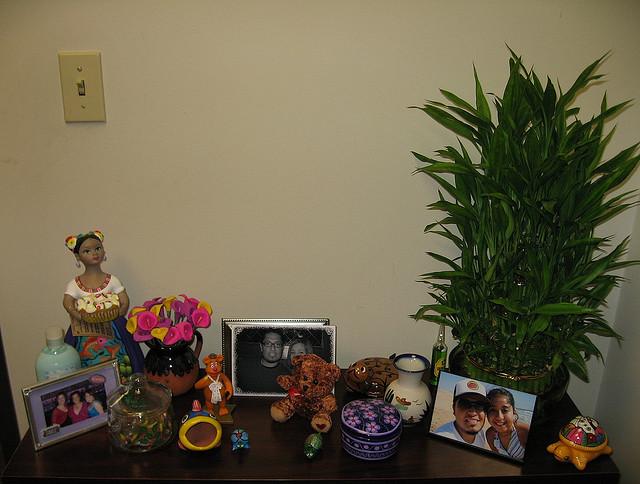Are these toys all manufactured by the same company?
Be succinct. No. Is the light on?
Answer briefly. Yes. Where is the photo album?
Quick response, please. Table. Is there a window in this room?
Keep it brief. No. How many teddy bears are in the image?
Keep it brief. 1. Are there many electronics?
Short answer required. No. Are some bears dressed as knights?
Write a very short answer. No. What is the purple and red figure on the tabletop?
Keep it brief. Jar. What kind of plants are in the pot?
Concise answer only. Fern. Is there a mirror in the picture?
Give a very brief answer. No. What are these dolls?
Be succinct. Stuffed. Is there a menu on the wall?
Write a very short answer. No. Where is a baby picture?
Write a very short answer. Nowhere. Are the objects in this picture orderly or messy?
Keep it brief. Orderly. How many bears are on the table?
Give a very brief answer. 2. How many bears are in the picture?
Keep it brief. 1. What kind of tree is it?
Keep it brief. Bamboo. What kind of plant is on the table?
Be succinct. Bamboo. What are these toys sitting on?
Give a very brief answer. Table. What is the round yellow object?
Concise answer only. Mouth. What manufacturer made the stuffed bear?
Concise answer only. Gund. How many bears are wearing pants?
Concise answer only. 0. What holiday are these people getting ready to celebrate?
Quick response, please. Christmas. How many dolls are seen?
Keep it brief. 3. Are the dolls wearing clothes?
Short answer required. Yes. Is this a display?
Answer briefly. Yes. How many hats are there?
Write a very short answer. 1. Are the bears suspended by something?
Short answer required. No. What color are the flowers?
Concise answer only. Pink and yellow. How many trees on the table?
Keep it brief. 1. Is there any cat statues in this photo?
Answer briefly. No. What color is the doll's hair?
Answer briefly. Black. What color is the toy?
Quick response, please. Orange. Is this flour or flower?
Concise answer only. Flower. Why do some photos have color and other do not?
Concise answer only. Black and white. What holiday does the center figurine represent?
Short answer required. Christmas. 